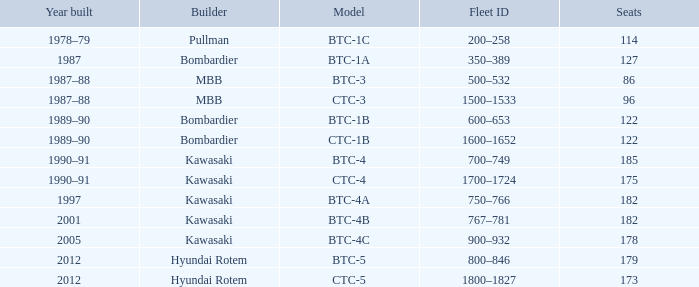How many people can the btc-5 model accommodate? 179.0. 